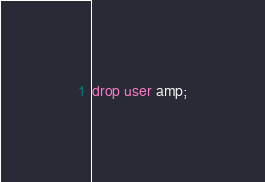Convert code to text. <code><loc_0><loc_0><loc_500><loc_500><_SQL_>drop user amp;
</code> 